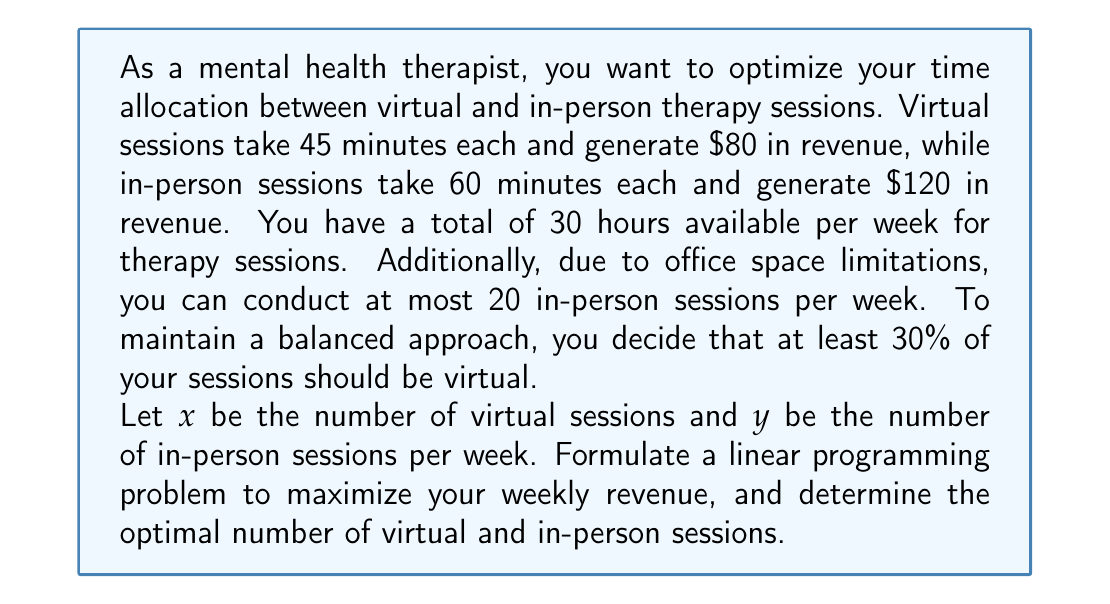Could you help me with this problem? To solve this problem, we'll follow these steps:

1. Define the objective function
2. Identify the constraints
3. Set up the linear programming problem
4. Solve the problem using the simplex method or graphical method

Step 1: Define the objective function

The objective is to maximize weekly revenue:
$$Z = 80x + 120y$$

Step 2: Identify the constraints

a) Time constraint: Total time for sessions ≤ 30 hours
$$45x + 60y \leq 1800$$ (1800 minutes = 30 hours)

b) In-person session limit: Maximum 20 in-person sessions
$$y \leq 20$$

c) Balanced approach: At least 30% of sessions should be virtual
$$x \geq 0.3(x + y)$$
$$0.7x - 0.3y \geq 0$$

d) Non-negativity constraints
$$x \geq 0, y \geq 0$$

Step 3: Set up the linear programming problem

Maximize: $Z = 80x + 120y$
Subject to:
$$45x + 60y \leq 1800$$
$$y \leq 20$$
$$0.7x - 0.3y \geq 0$$
$$x \geq 0, y \geq 0$$

Step 4: Solve the problem

Using the simplex method or graphical method, we can solve this linear programming problem. The optimal solution is:

$$x = 24$$
$$y = 20$$

This means the therapist should conduct 24 virtual sessions and 20 in-person sessions per week.

The maximum weekly revenue is:
$$Z = 80(24) + 120(20) = 1920 + 2400 = 4320$$
Answer: The optimal allocation is 24 virtual sessions and 20 in-person sessions per week, generating a maximum weekly revenue of $4320. 